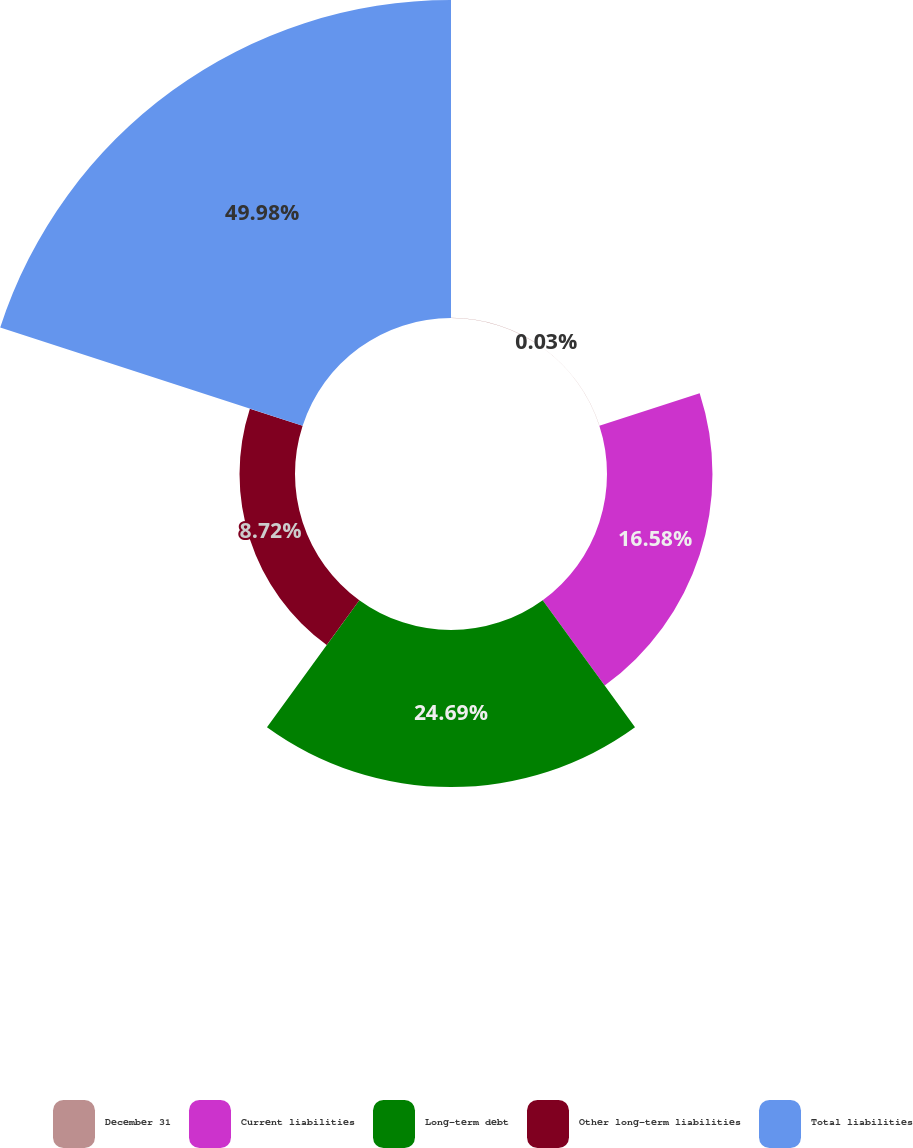Convert chart to OTSL. <chart><loc_0><loc_0><loc_500><loc_500><pie_chart><fcel>December 31<fcel>Current liabilities<fcel>Long-term debt<fcel>Other long-term liabilities<fcel>Total liabilities<nl><fcel>0.03%<fcel>16.58%<fcel>24.69%<fcel>8.72%<fcel>49.99%<nl></chart> 